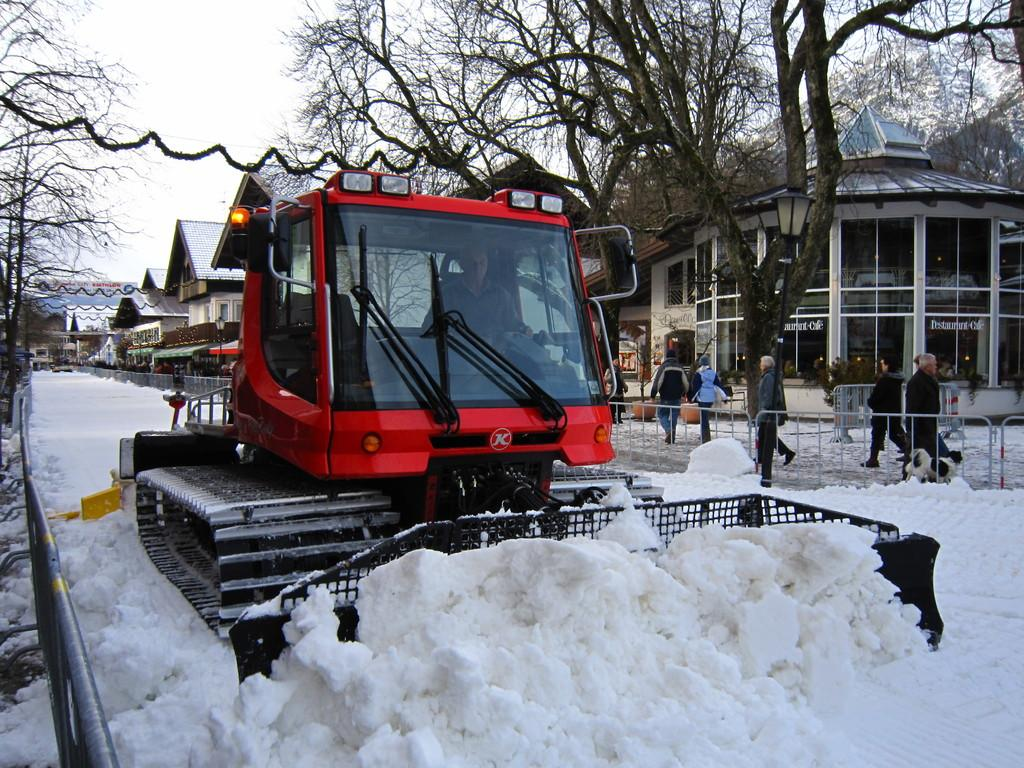What type of machinery is present in the image? There is an excavator in the image. What is the weather like in the image? There is snow in the image, indicating a cold or wintery environment. What type of barrier can be seen in the image? There is a fence in the image. What type of vegetation is present in the image? There are plants and trees in the image. What type of construction material is present in the image? There are boards in the image. What type of illumination is present in the image? There is a light in the image. What type of structures are present in the image? There are buildings in the image. Are there any people present in the image? Yes, there are people in the image. What can be seen in the background of the image? The sky is visible in the background of the image. What type of pickle is being used to build the fence in the image? There is no pickle present in the image, and therefore no such activity can be observed. Can you describe the sheet that the people are using to walk on in the image? There is no sheet present in the image, and no one is walking on any surface other than the ground. 